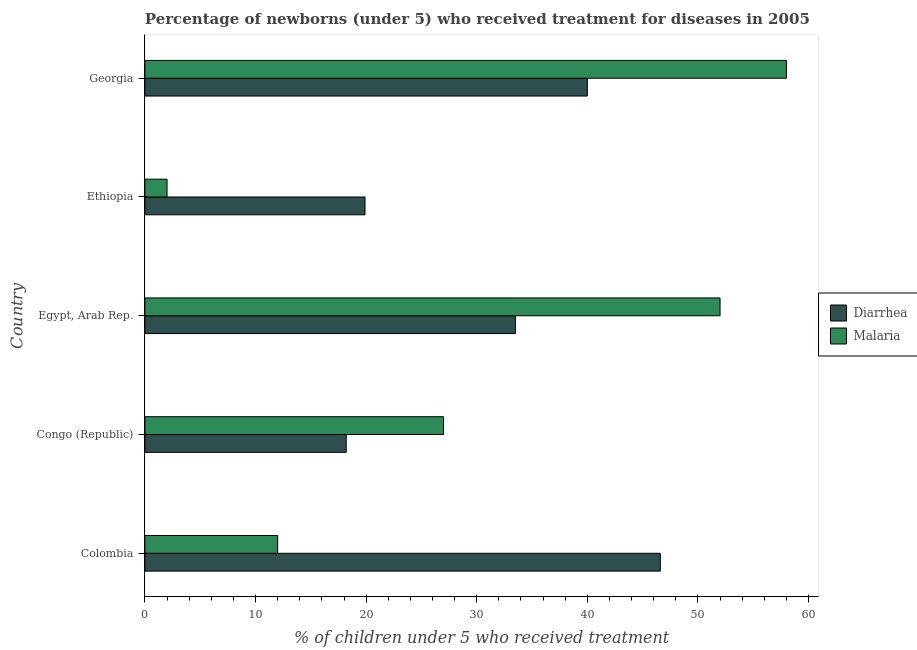Are the number of bars on each tick of the Y-axis equal?
Offer a very short reply. Yes. How many bars are there on the 2nd tick from the top?
Provide a short and direct response. 2. How many bars are there on the 4th tick from the bottom?
Provide a succinct answer. 2. What is the label of the 2nd group of bars from the top?
Provide a succinct answer. Ethiopia. What is the percentage of children who received treatment for malaria in Congo (Republic)?
Make the answer very short. 27. In which country was the percentage of children who received treatment for diarrhoea maximum?
Offer a terse response. Colombia. In which country was the percentage of children who received treatment for malaria minimum?
Provide a short and direct response. Ethiopia. What is the total percentage of children who received treatment for diarrhoea in the graph?
Keep it short and to the point. 158.2. What is the difference between the percentage of children who received treatment for diarrhoea in Congo (Republic) and that in Georgia?
Your response must be concise. -21.8. What is the average percentage of children who received treatment for diarrhoea per country?
Ensure brevity in your answer.  31.64. In how many countries, is the percentage of children who received treatment for diarrhoea greater than 40 %?
Provide a succinct answer. 1. What is the ratio of the percentage of children who received treatment for malaria in Congo (Republic) to that in Georgia?
Offer a very short reply. 0.47. What is the difference between the highest and the second highest percentage of children who received treatment for malaria?
Your response must be concise. 6. What is the difference between the highest and the lowest percentage of children who received treatment for diarrhoea?
Provide a succinct answer. 28.4. What does the 2nd bar from the top in Egypt, Arab Rep. represents?
Provide a succinct answer. Diarrhea. What does the 1st bar from the bottom in Georgia represents?
Provide a succinct answer. Diarrhea. Are all the bars in the graph horizontal?
Provide a short and direct response. Yes. What is the difference between two consecutive major ticks on the X-axis?
Give a very brief answer. 10. Does the graph contain any zero values?
Your answer should be very brief. No. Where does the legend appear in the graph?
Make the answer very short. Center right. What is the title of the graph?
Give a very brief answer. Percentage of newborns (under 5) who received treatment for diseases in 2005. Does "Arms imports" appear as one of the legend labels in the graph?
Ensure brevity in your answer.  No. What is the label or title of the X-axis?
Offer a terse response. % of children under 5 who received treatment. What is the % of children under 5 who received treatment of Diarrhea in Colombia?
Make the answer very short. 46.6. What is the % of children under 5 who received treatment in Malaria in Colombia?
Your answer should be compact. 12. What is the % of children under 5 who received treatment of Diarrhea in Congo (Republic)?
Your answer should be compact. 18.2. What is the % of children under 5 who received treatment in Malaria in Congo (Republic)?
Keep it short and to the point. 27. What is the % of children under 5 who received treatment in Diarrhea in Egypt, Arab Rep.?
Provide a short and direct response. 33.5. What is the % of children under 5 who received treatment of Diarrhea in Ethiopia?
Your answer should be compact. 19.9. What is the % of children under 5 who received treatment of Malaria in Ethiopia?
Ensure brevity in your answer.  2. What is the % of children under 5 who received treatment of Malaria in Georgia?
Provide a short and direct response. 58. Across all countries, what is the maximum % of children under 5 who received treatment in Diarrhea?
Your answer should be very brief. 46.6. Across all countries, what is the maximum % of children under 5 who received treatment of Malaria?
Your answer should be compact. 58. What is the total % of children under 5 who received treatment in Diarrhea in the graph?
Your answer should be compact. 158.2. What is the total % of children under 5 who received treatment of Malaria in the graph?
Your answer should be compact. 151. What is the difference between the % of children under 5 who received treatment of Diarrhea in Colombia and that in Congo (Republic)?
Offer a terse response. 28.4. What is the difference between the % of children under 5 who received treatment of Diarrhea in Colombia and that in Egypt, Arab Rep.?
Offer a very short reply. 13.1. What is the difference between the % of children under 5 who received treatment in Malaria in Colombia and that in Egypt, Arab Rep.?
Your response must be concise. -40. What is the difference between the % of children under 5 who received treatment of Diarrhea in Colombia and that in Ethiopia?
Provide a short and direct response. 26.7. What is the difference between the % of children under 5 who received treatment of Malaria in Colombia and that in Ethiopia?
Offer a terse response. 10. What is the difference between the % of children under 5 who received treatment in Malaria in Colombia and that in Georgia?
Provide a succinct answer. -46. What is the difference between the % of children under 5 who received treatment in Diarrhea in Congo (Republic) and that in Egypt, Arab Rep.?
Your answer should be compact. -15.3. What is the difference between the % of children under 5 who received treatment in Diarrhea in Congo (Republic) and that in Ethiopia?
Give a very brief answer. -1.7. What is the difference between the % of children under 5 who received treatment of Diarrhea in Congo (Republic) and that in Georgia?
Offer a very short reply. -21.8. What is the difference between the % of children under 5 who received treatment of Malaria in Congo (Republic) and that in Georgia?
Your answer should be very brief. -31. What is the difference between the % of children under 5 who received treatment of Malaria in Egypt, Arab Rep. and that in Georgia?
Ensure brevity in your answer.  -6. What is the difference between the % of children under 5 who received treatment of Diarrhea in Ethiopia and that in Georgia?
Provide a short and direct response. -20.1. What is the difference between the % of children under 5 who received treatment in Malaria in Ethiopia and that in Georgia?
Provide a succinct answer. -56. What is the difference between the % of children under 5 who received treatment in Diarrhea in Colombia and the % of children under 5 who received treatment in Malaria in Congo (Republic)?
Give a very brief answer. 19.6. What is the difference between the % of children under 5 who received treatment of Diarrhea in Colombia and the % of children under 5 who received treatment of Malaria in Ethiopia?
Your answer should be very brief. 44.6. What is the difference between the % of children under 5 who received treatment in Diarrhea in Colombia and the % of children under 5 who received treatment in Malaria in Georgia?
Keep it short and to the point. -11.4. What is the difference between the % of children under 5 who received treatment in Diarrhea in Congo (Republic) and the % of children under 5 who received treatment in Malaria in Egypt, Arab Rep.?
Your response must be concise. -33.8. What is the difference between the % of children under 5 who received treatment of Diarrhea in Congo (Republic) and the % of children under 5 who received treatment of Malaria in Georgia?
Offer a very short reply. -39.8. What is the difference between the % of children under 5 who received treatment of Diarrhea in Egypt, Arab Rep. and the % of children under 5 who received treatment of Malaria in Ethiopia?
Provide a succinct answer. 31.5. What is the difference between the % of children under 5 who received treatment of Diarrhea in Egypt, Arab Rep. and the % of children under 5 who received treatment of Malaria in Georgia?
Ensure brevity in your answer.  -24.5. What is the difference between the % of children under 5 who received treatment in Diarrhea in Ethiopia and the % of children under 5 who received treatment in Malaria in Georgia?
Make the answer very short. -38.1. What is the average % of children under 5 who received treatment of Diarrhea per country?
Offer a terse response. 31.64. What is the average % of children under 5 who received treatment of Malaria per country?
Your answer should be very brief. 30.2. What is the difference between the % of children under 5 who received treatment in Diarrhea and % of children under 5 who received treatment in Malaria in Colombia?
Ensure brevity in your answer.  34.6. What is the difference between the % of children under 5 who received treatment in Diarrhea and % of children under 5 who received treatment in Malaria in Congo (Republic)?
Ensure brevity in your answer.  -8.8. What is the difference between the % of children under 5 who received treatment in Diarrhea and % of children under 5 who received treatment in Malaria in Egypt, Arab Rep.?
Your answer should be very brief. -18.5. What is the difference between the % of children under 5 who received treatment of Diarrhea and % of children under 5 who received treatment of Malaria in Ethiopia?
Make the answer very short. 17.9. What is the ratio of the % of children under 5 who received treatment in Diarrhea in Colombia to that in Congo (Republic)?
Keep it short and to the point. 2.56. What is the ratio of the % of children under 5 who received treatment of Malaria in Colombia to that in Congo (Republic)?
Give a very brief answer. 0.44. What is the ratio of the % of children under 5 who received treatment in Diarrhea in Colombia to that in Egypt, Arab Rep.?
Offer a very short reply. 1.39. What is the ratio of the % of children under 5 who received treatment in Malaria in Colombia to that in Egypt, Arab Rep.?
Give a very brief answer. 0.23. What is the ratio of the % of children under 5 who received treatment in Diarrhea in Colombia to that in Ethiopia?
Your response must be concise. 2.34. What is the ratio of the % of children under 5 who received treatment of Diarrhea in Colombia to that in Georgia?
Make the answer very short. 1.17. What is the ratio of the % of children under 5 who received treatment in Malaria in Colombia to that in Georgia?
Keep it short and to the point. 0.21. What is the ratio of the % of children under 5 who received treatment in Diarrhea in Congo (Republic) to that in Egypt, Arab Rep.?
Keep it short and to the point. 0.54. What is the ratio of the % of children under 5 who received treatment of Malaria in Congo (Republic) to that in Egypt, Arab Rep.?
Your answer should be very brief. 0.52. What is the ratio of the % of children under 5 who received treatment of Diarrhea in Congo (Republic) to that in Ethiopia?
Provide a succinct answer. 0.91. What is the ratio of the % of children under 5 who received treatment in Malaria in Congo (Republic) to that in Ethiopia?
Offer a very short reply. 13.5. What is the ratio of the % of children under 5 who received treatment of Diarrhea in Congo (Republic) to that in Georgia?
Your response must be concise. 0.46. What is the ratio of the % of children under 5 who received treatment in Malaria in Congo (Republic) to that in Georgia?
Provide a short and direct response. 0.47. What is the ratio of the % of children under 5 who received treatment in Diarrhea in Egypt, Arab Rep. to that in Ethiopia?
Offer a very short reply. 1.68. What is the ratio of the % of children under 5 who received treatment in Malaria in Egypt, Arab Rep. to that in Ethiopia?
Your answer should be very brief. 26. What is the ratio of the % of children under 5 who received treatment in Diarrhea in Egypt, Arab Rep. to that in Georgia?
Your answer should be very brief. 0.84. What is the ratio of the % of children under 5 who received treatment of Malaria in Egypt, Arab Rep. to that in Georgia?
Your answer should be very brief. 0.9. What is the ratio of the % of children under 5 who received treatment in Diarrhea in Ethiopia to that in Georgia?
Provide a succinct answer. 0.5. What is the ratio of the % of children under 5 who received treatment in Malaria in Ethiopia to that in Georgia?
Make the answer very short. 0.03. What is the difference between the highest and the second highest % of children under 5 who received treatment in Malaria?
Keep it short and to the point. 6. What is the difference between the highest and the lowest % of children under 5 who received treatment of Diarrhea?
Offer a terse response. 28.4. What is the difference between the highest and the lowest % of children under 5 who received treatment of Malaria?
Make the answer very short. 56. 